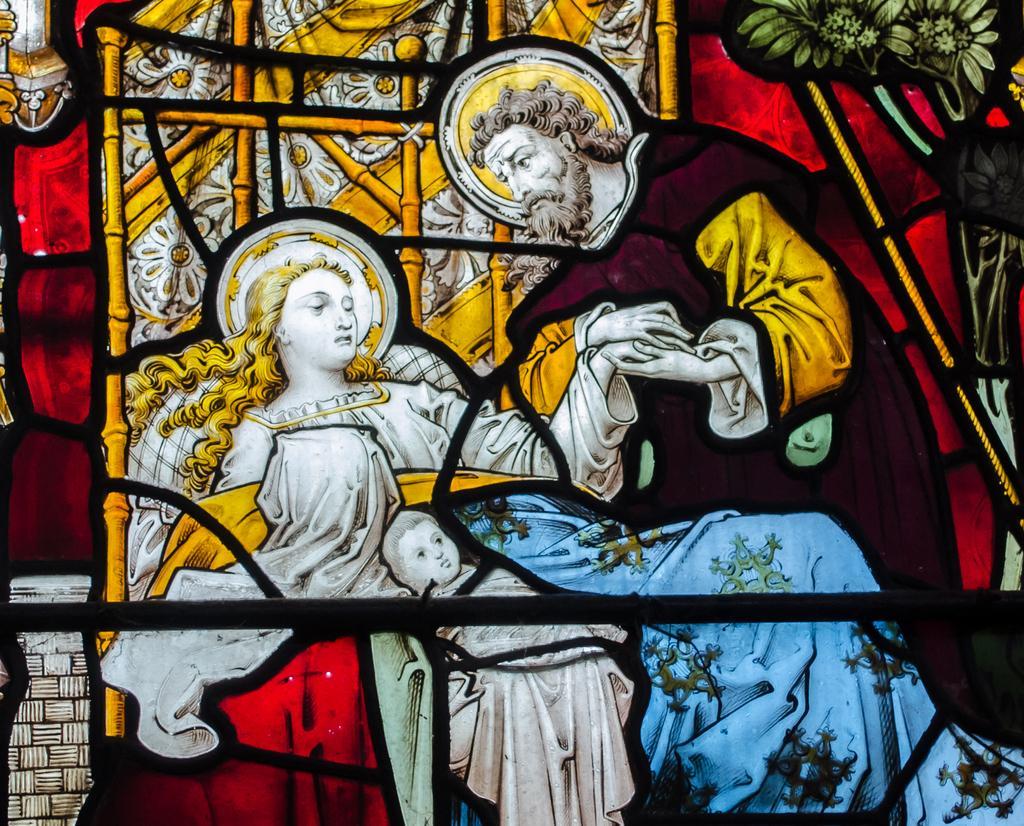How would you summarize this image in a sentence or two? In this image we can see the painting of the persons. In the top right, we can see the flowers. Behind the persons we can see the sticks. 